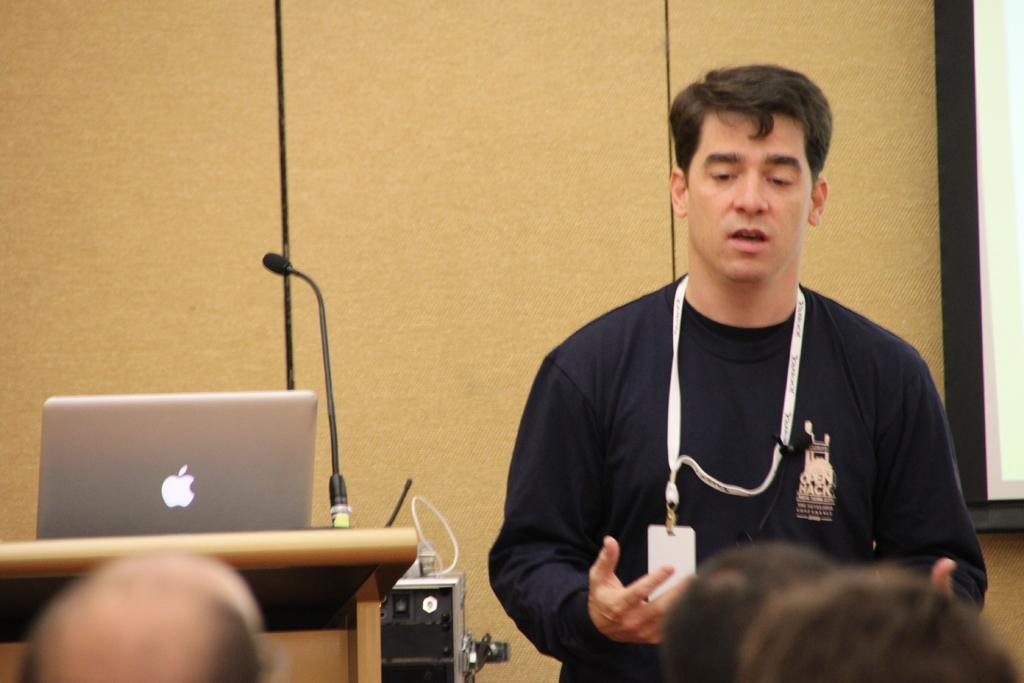What is the main subject of the image? The main subject of the image is a man. What is the man doing in the image? The man is standing and talking. What is the man wearing in the image? The man is wearing a t-shirt. Does the man have any identification in the image? Yes, the man has an ID card. What objects are on the left side of the image? There is a laptop and a microphone on the left side of the image. What is the man fighting with in the image? There is no fighting depicted in the image; the man is simply standing and talking. How does the man's breath affect the objects in the image? The man's breath is not visible or mentioned in the image, so it cannot be determined how it might affect the objects. 